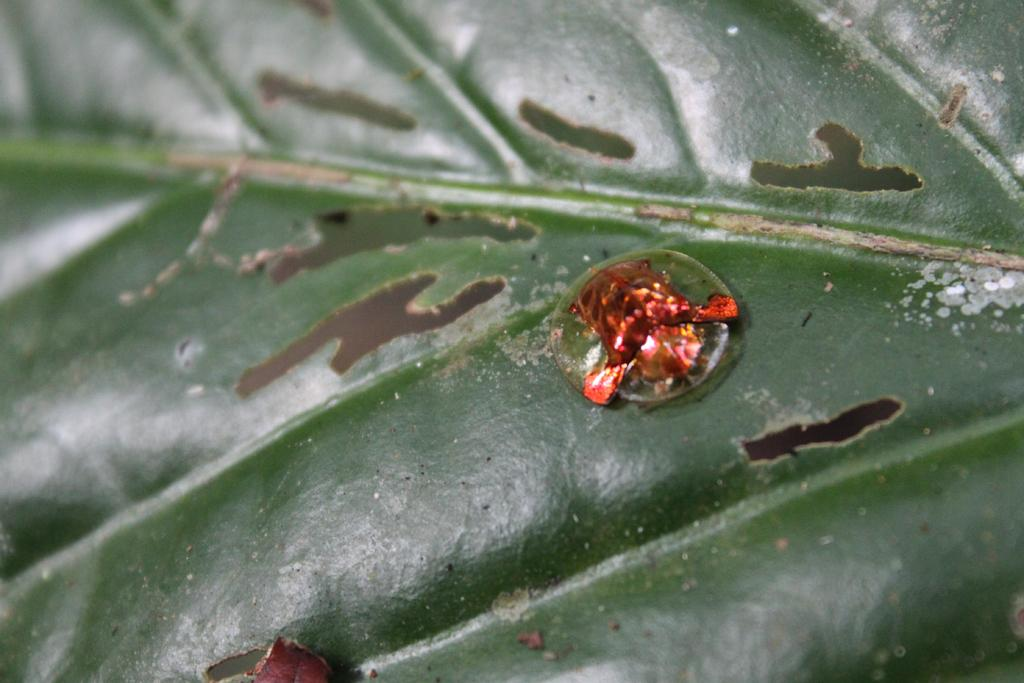What is present in the image? There is a leaf in the image. What can be said about the color of the leaf? The leaf is green in color. How many grapes are hanging from the leaf in the image? There are no grapes present in the image; it only features a leaf. What type of ice is visible on the leaf in the image? There is no ice present on the leaf in the image; it is a green leaf. 